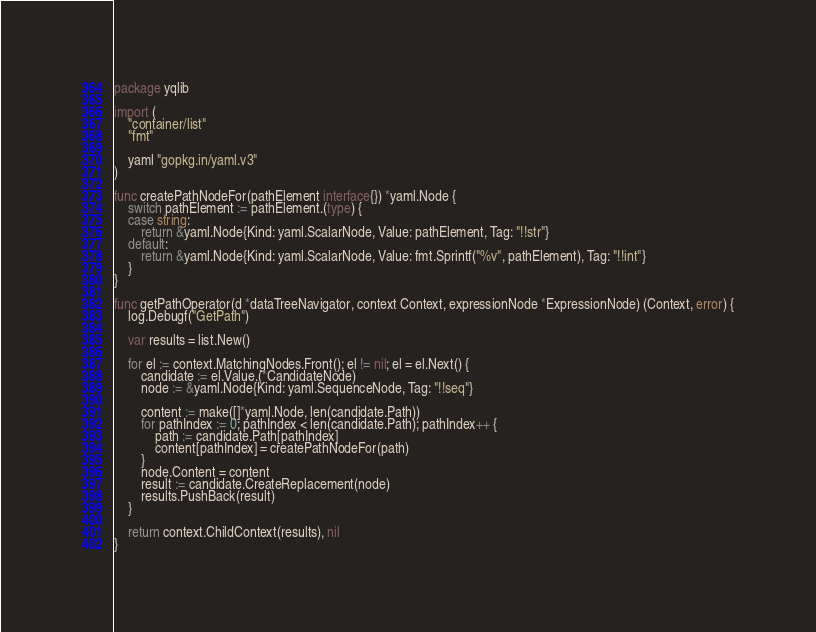Convert code to text. <code><loc_0><loc_0><loc_500><loc_500><_Go_>package yqlib

import (
	"container/list"
	"fmt"

	yaml "gopkg.in/yaml.v3"
)

func createPathNodeFor(pathElement interface{}) *yaml.Node {
	switch pathElement := pathElement.(type) {
	case string:
		return &yaml.Node{Kind: yaml.ScalarNode, Value: pathElement, Tag: "!!str"}
	default:
		return &yaml.Node{Kind: yaml.ScalarNode, Value: fmt.Sprintf("%v", pathElement), Tag: "!!int"}
	}
}

func getPathOperator(d *dataTreeNavigator, context Context, expressionNode *ExpressionNode) (Context, error) {
	log.Debugf("GetPath")

	var results = list.New()

	for el := context.MatchingNodes.Front(); el != nil; el = el.Next() {
		candidate := el.Value.(*CandidateNode)
		node := &yaml.Node{Kind: yaml.SequenceNode, Tag: "!!seq"}

		content := make([]*yaml.Node, len(candidate.Path))
		for pathIndex := 0; pathIndex < len(candidate.Path); pathIndex++ {
			path := candidate.Path[pathIndex]
			content[pathIndex] = createPathNodeFor(path)
		}
		node.Content = content
		result := candidate.CreateReplacement(node)
		results.PushBack(result)
	}

	return context.ChildContext(results), nil
}
</code> 